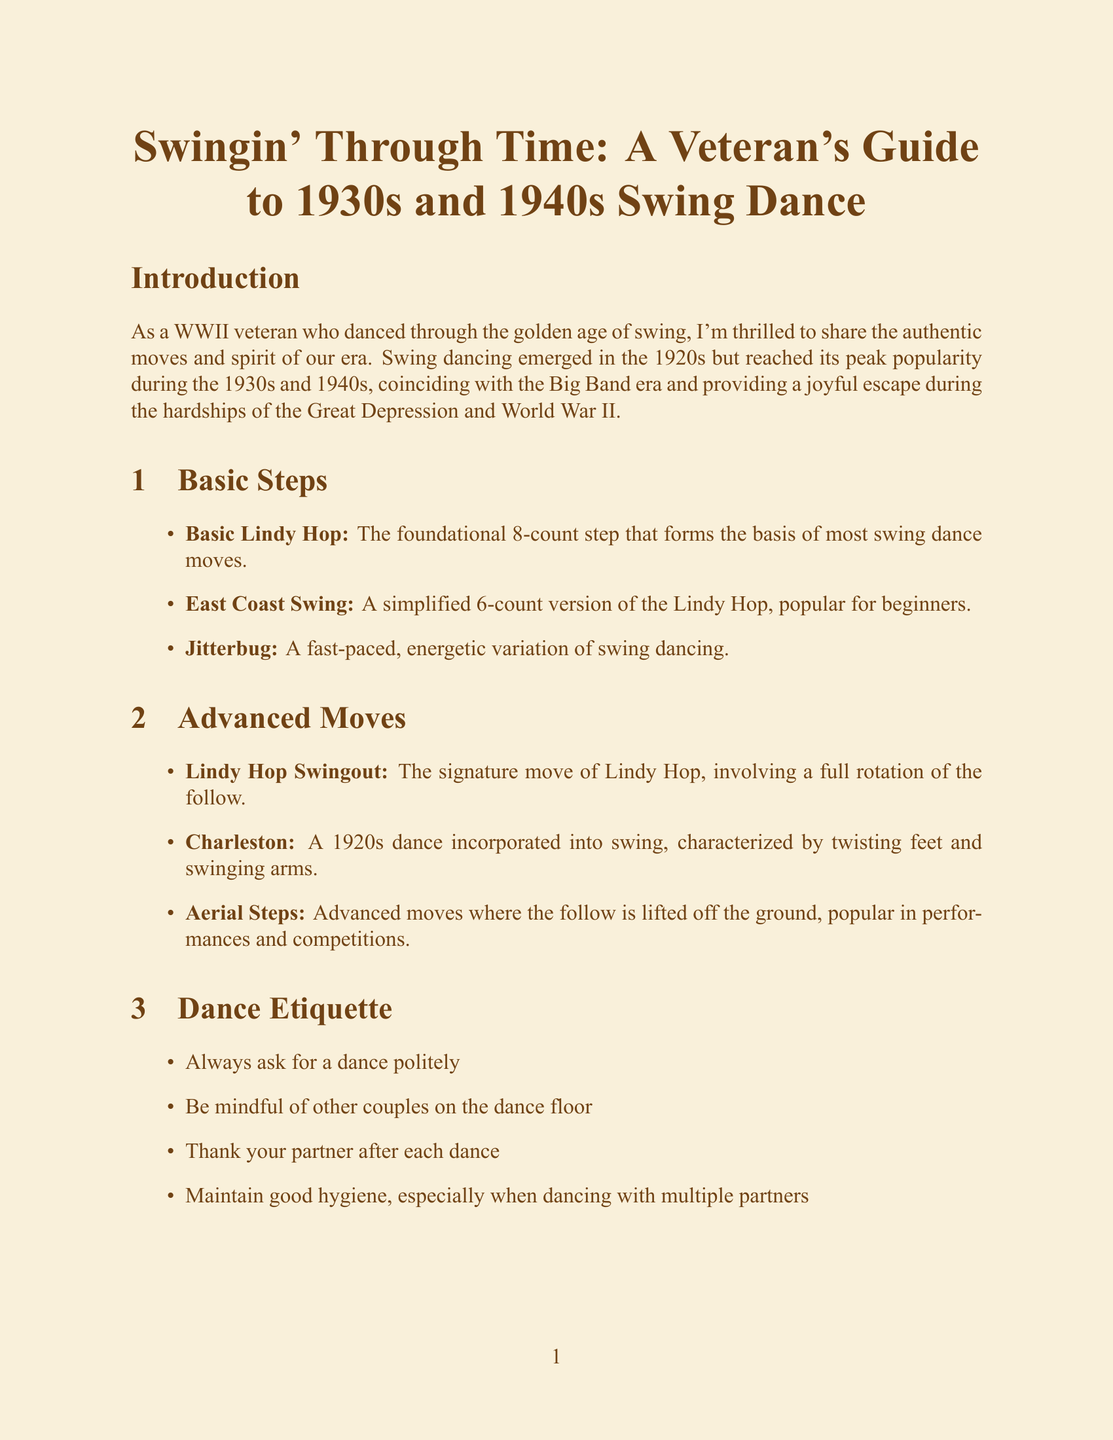What is the title of the guide? The title is the main heading of the document, indicating its purpose and content.
Answer: Swingin' Through Time: A Veteran's Guide to 1930s and 1940s Swing Dance How many basic steps are listed in the document? The document features a section that enumerates various basic steps available.
Answer: 3 What is the signature move of Lindy Hop? The document describes a specific advanced move that is known as the hallmark of Lindy Hop.
Answer: Lindy Hop Swingout Which hairstyle was popular for women dancers during wartime? The document mentions a specific hairstyle associated with women dancers, highlighting its cultural significance.
Answer: Victory rolls What city is the Savoy Ballroom located in? The document indicates the location of a famous venue known for its significant role in swing dance history.
Answer: Harlem, New York City What decade saw a revival of interest in swing dancing? The manual states a particular decade that witnessed a renewed interest in swing dancing, reflecting its cultural resurgence.
Answer: 1980s Name one famous song by Count Basie. The document lists songs associated with music bands, specifically mentioning famous tunes from Count Basie.
Answer: One O'Clock Jump What is the effect of fabric rationing on women's dress designs? The document discusses a consequence of rationing during wartime that influenced women's fashion in dance.
Answer: Shorter skirts and simpler dress designs 